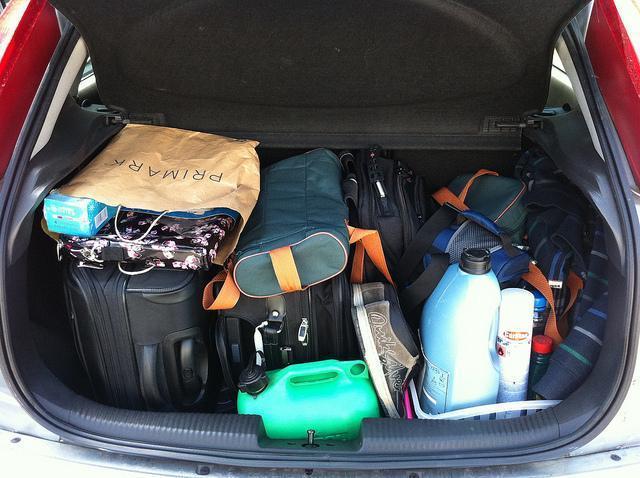How many backpacks can be seen?
Give a very brief answer. 2. How many suitcases are in the picture?
Give a very brief answer. 2. How many bottles are in the picture?
Give a very brief answer. 2. 